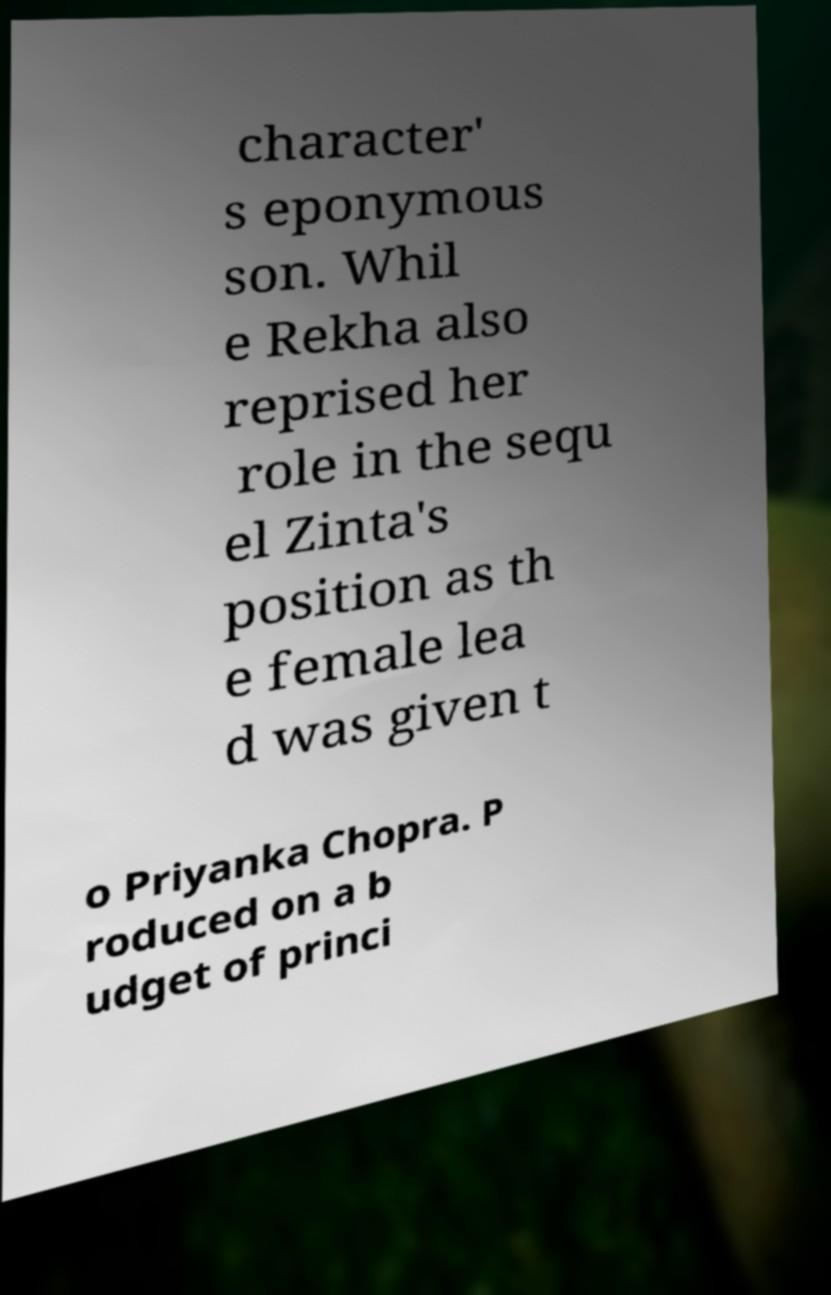Please read and relay the text visible in this image. What does it say? character' s eponymous son. Whil e Rekha also reprised her role in the sequ el Zinta's position as th e female lea d was given t o Priyanka Chopra. P roduced on a b udget of princi 